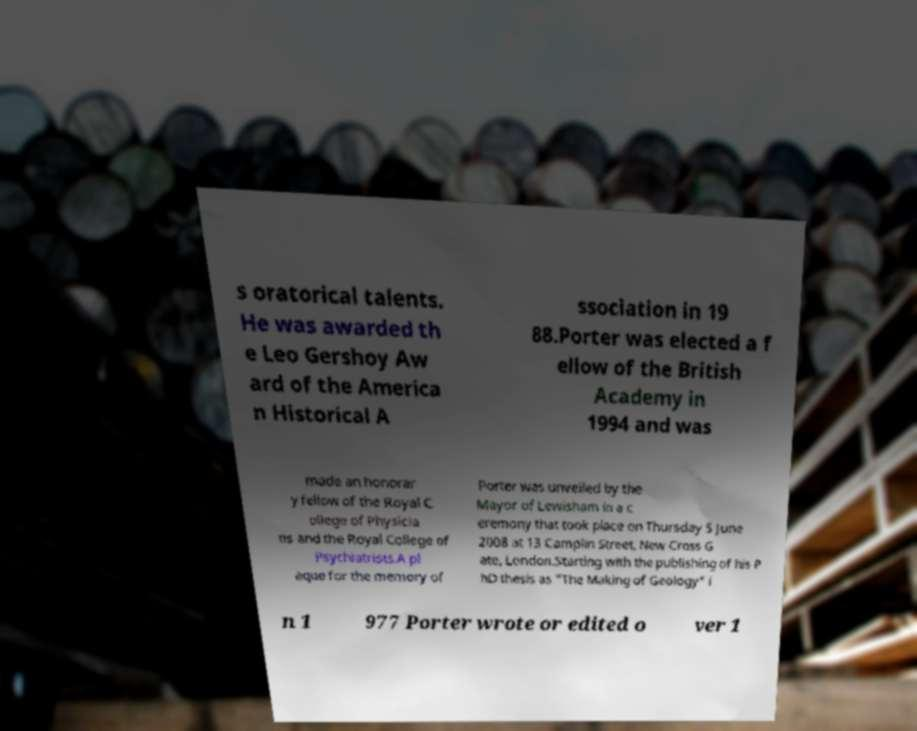Could you extract and type out the text from this image? s oratorical talents. He was awarded th e Leo Gershoy Aw ard of the America n Historical A ssociation in 19 88.Porter was elected a f ellow of the British Academy in 1994 and was made an honorar y fellow of the Royal C ollege of Physicia ns and the Royal College of Psychiatrists.A pl aque for the memory of Porter was unveiled by the Mayor of Lewisham in a c eremony that took place on Thursday 5 June 2008 at 13 Camplin Street, New Cross G ate, London.Starting with the publishing of his P hD thesis as "The Making of Geology" i n 1 977 Porter wrote or edited o ver 1 